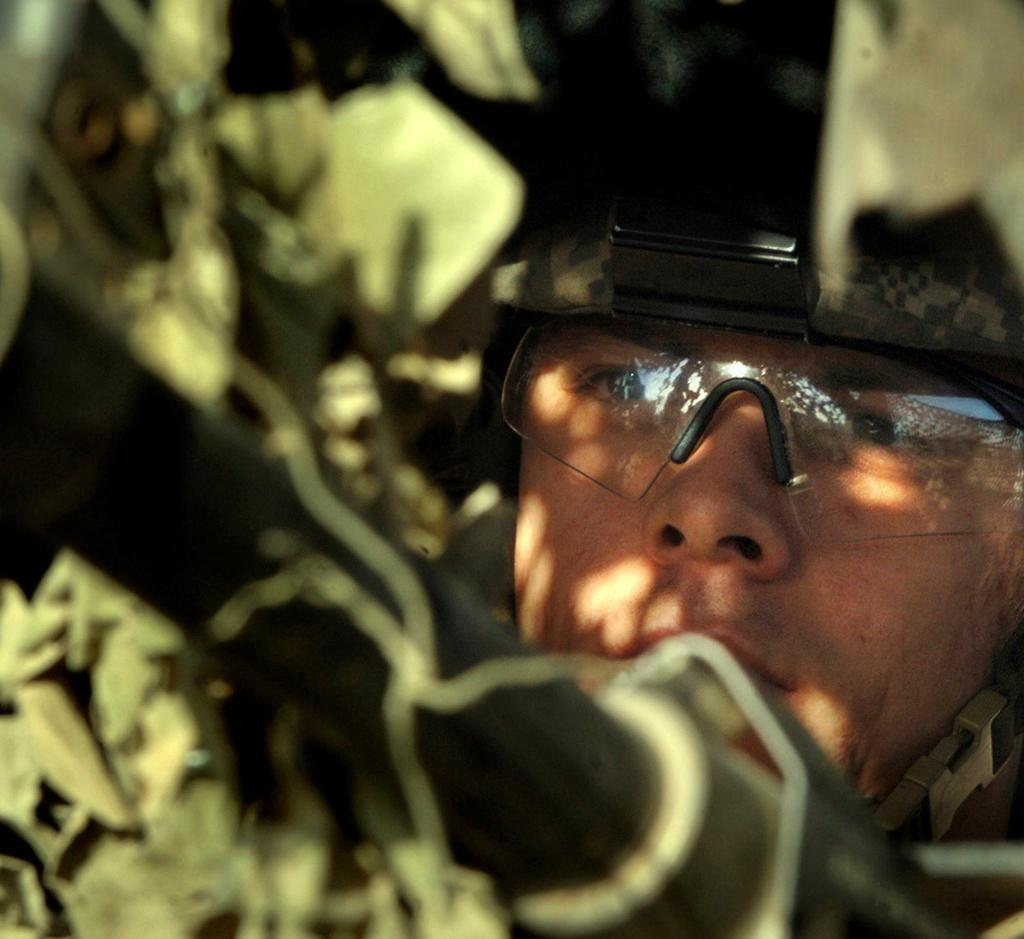Who is present in the image? There is a man in the image. What protective gear is the man wearing? The man is wearing goggles and a helmet. Can you describe the objects at the top of the image? There are objects towards the top of the image, but their specific details are not mentioned in the facts. Can you describe the objects at the bottom of the image? There are objects towards the bottom of the image, but their specific details are not mentioned in the facts. Where is the baby located in the image? There is no baby present in the image. What type of flooring can be seen in the image? The facts do not mention any flooring in the image. 